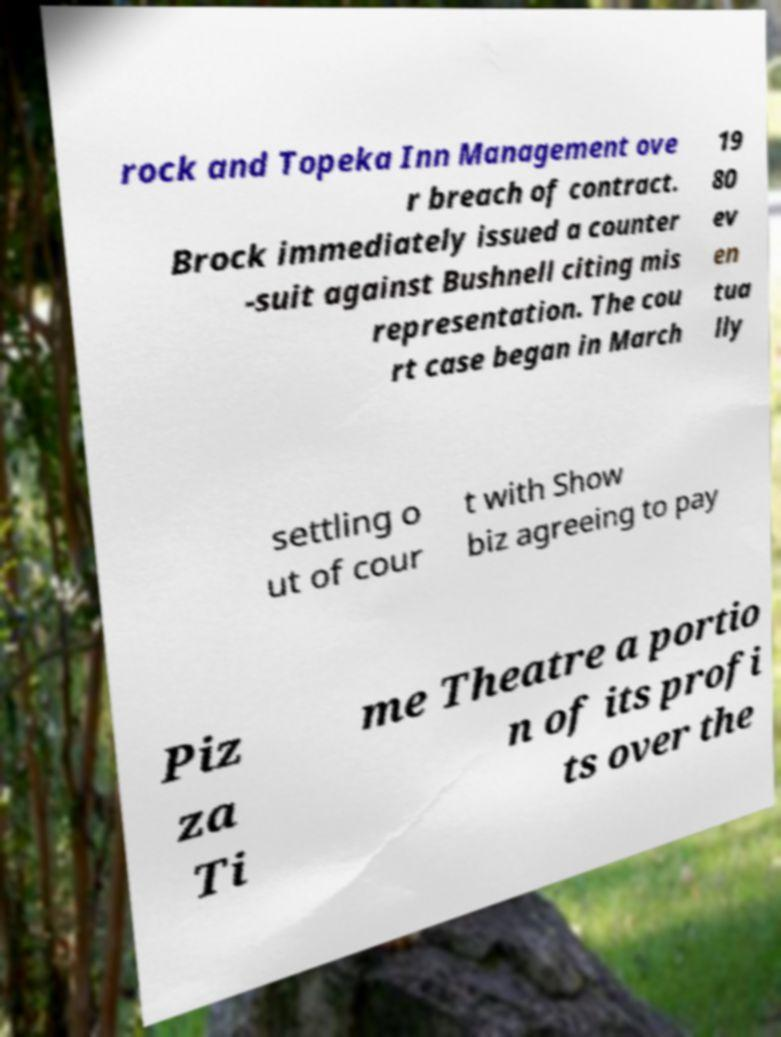Can you accurately transcribe the text from the provided image for me? rock and Topeka Inn Management ove r breach of contract. Brock immediately issued a counter -suit against Bushnell citing mis representation. The cou rt case began in March 19 80 ev en tua lly settling o ut of cour t with Show biz agreeing to pay Piz za Ti me Theatre a portio n of its profi ts over the 